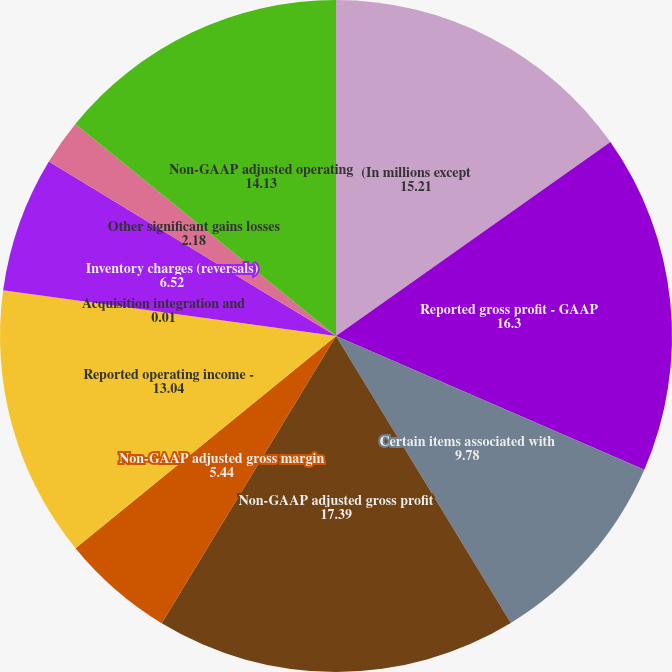<chart> <loc_0><loc_0><loc_500><loc_500><pie_chart><fcel>(In millions except<fcel>Reported gross profit - GAAP<fcel>Certain items associated with<fcel>Non-GAAP adjusted gross profit<fcel>Non-GAAP adjusted gross margin<fcel>Reported operating income -<fcel>Acquisition integration and<fcel>Inventory charges (reversals)<fcel>Other significant gains losses<fcel>Non-GAAP adjusted operating<nl><fcel>15.21%<fcel>16.3%<fcel>9.78%<fcel>17.39%<fcel>5.44%<fcel>13.04%<fcel>0.01%<fcel>6.52%<fcel>2.18%<fcel>14.13%<nl></chart> 